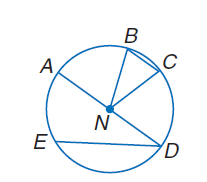Question: If A N is 5 meters long, find the exact circumference of \odot N.
Choices:
A. \pi
B. 10
C. 5 \pi
D. 10 \pi
Answer with the letter. Answer: D Question: If m \widehat B C = 30 and A B \cong \widehat C D, find m \widehat A B.
Choices:
A. 75
B. 90
C. 105
D. 120
Answer with the letter. Answer: A Question: If B E \cong E D and m \widehat E D = 120, find m \widehat B E.
Choices:
A. 120
B. 135
C. 160
D. 175
Answer with the letter. Answer: A Question: If A D = 24, find C N.
Choices:
A. 12
B. 36
C. 48
D. 60
Answer with the letter. Answer: A 